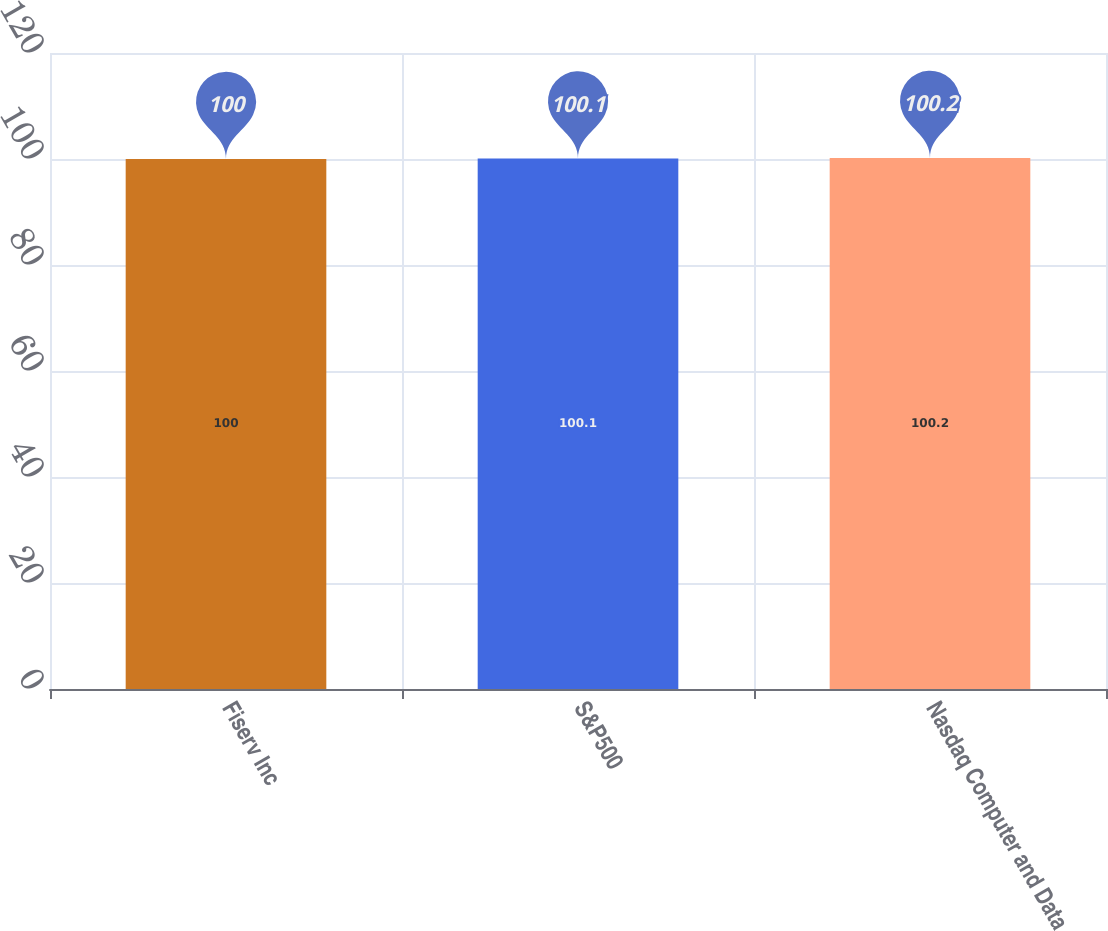Convert chart to OTSL. <chart><loc_0><loc_0><loc_500><loc_500><bar_chart><fcel>Fiserv Inc<fcel>S&P500<fcel>Nasdaq Computer and Data<nl><fcel>100<fcel>100.1<fcel>100.2<nl></chart> 